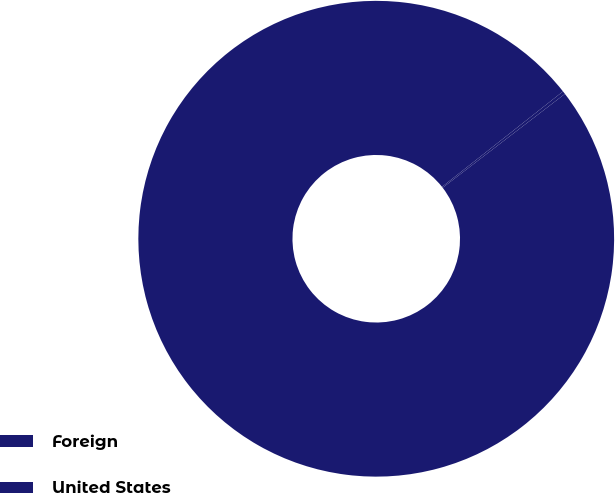<chart> <loc_0><loc_0><loc_500><loc_500><pie_chart><fcel>Foreign<fcel>United States<nl><fcel>99.79%<fcel>0.21%<nl></chart> 